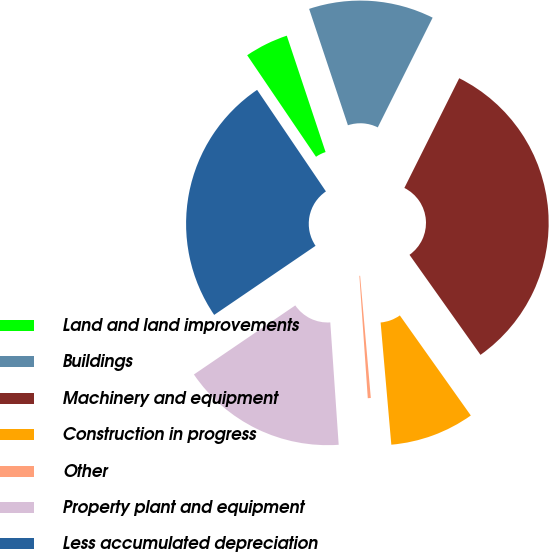Convert chart to OTSL. <chart><loc_0><loc_0><loc_500><loc_500><pie_chart><fcel>Land and land improvements<fcel>Buildings<fcel>Machinery and equipment<fcel>Construction in progress<fcel>Other<fcel>Property plant and equipment<fcel>Less accumulated depreciation<nl><fcel>4.36%<fcel>12.5%<fcel>32.8%<fcel>8.43%<fcel>0.3%<fcel>16.57%<fcel>25.04%<nl></chart> 